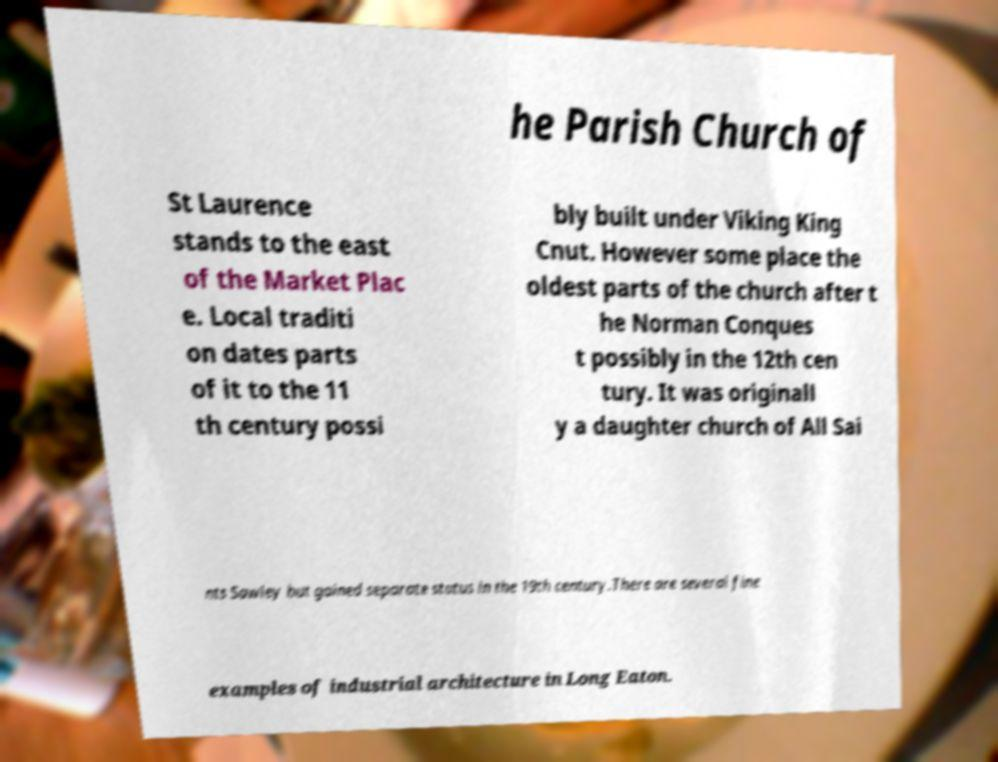For documentation purposes, I need the text within this image transcribed. Could you provide that? he Parish Church of St Laurence stands to the east of the Market Plac e. Local traditi on dates parts of it to the 11 th century possi bly built under Viking King Cnut. However some place the oldest parts of the church after t he Norman Conques t possibly in the 12th cen tury. It was originall y a daughter church of All Sai nts Sawley but gained separate status in the 19th century.There are several fine examples of industrial architecture in Long Eaton. 